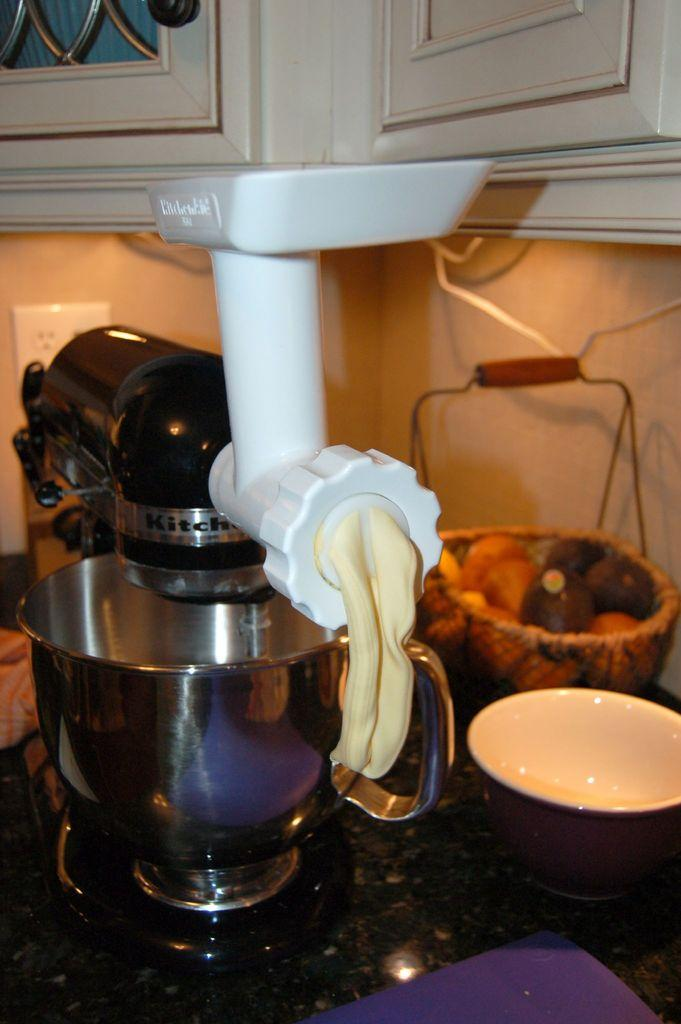<image>
Write a terse but informative summary of the picture. A Kitchen-Aid mixer with an attachment for dispensing semi liquid substances. 